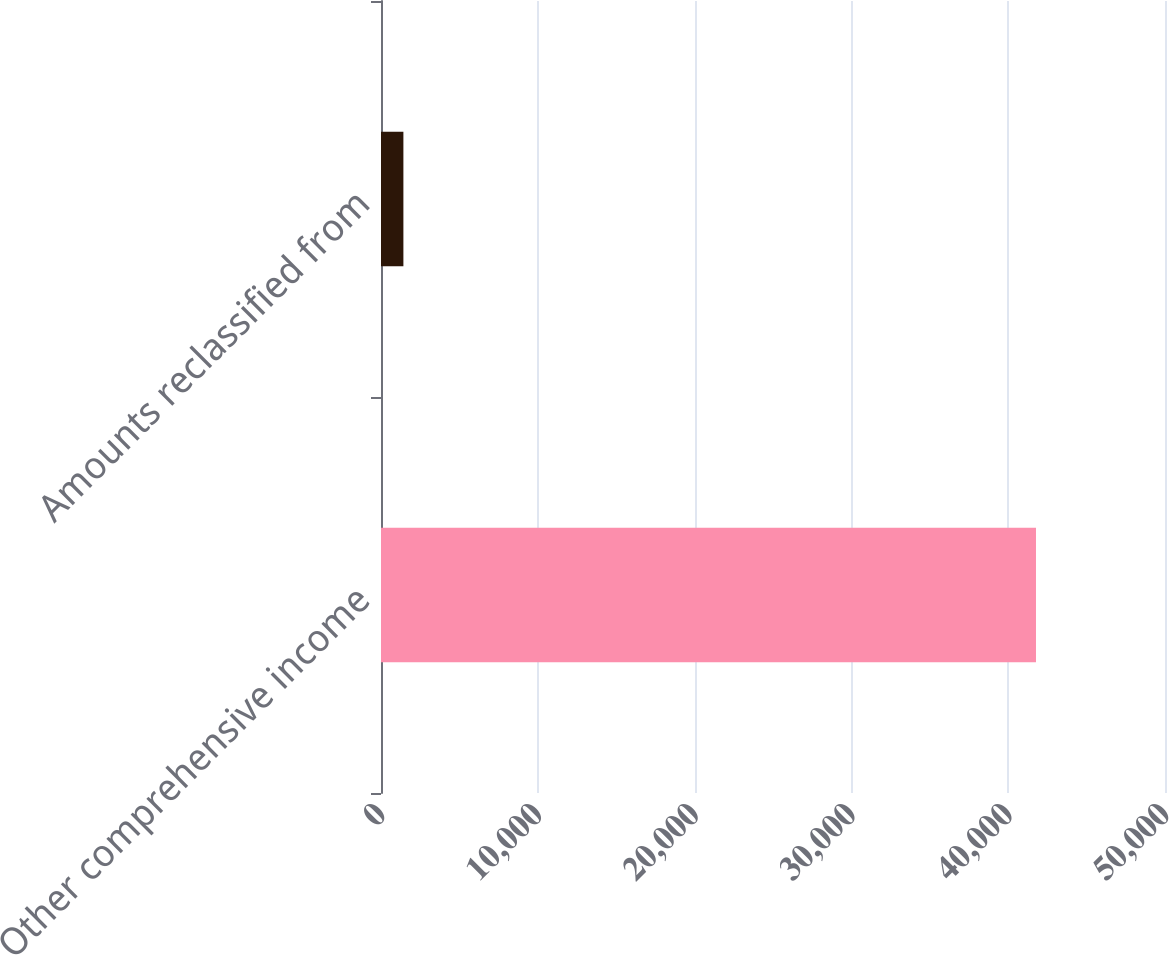Convert chart. <chart><loc_0><loc_0><loc_500><loc_500><bar_chart><fcel>Other comprehensive income<fcel>Amounts reclassified from<nl><fcel>41772<fcel>1428<nl></chart> 